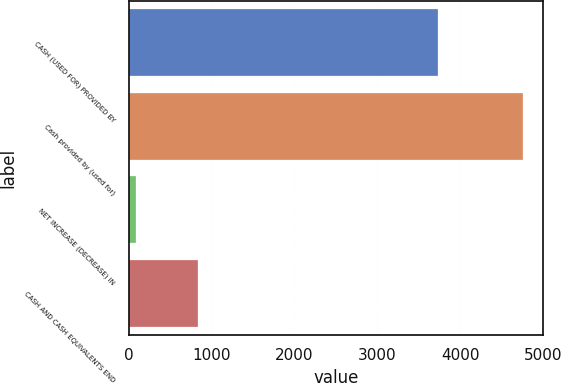Convert chart. <chart><loc_0><loc_0><loc_500><loc_500><bar_chart><fcel>CASH (USED FOR) PROVIDED BY<fcel>Cash provided by (used for)<fcel>NET INCREASE (DECREASE) IN<fcel>CASH AND CASH EQUIVALENTS END<nl><fcel>3731<fcel>4762<fcel>80<fcel>836<nl></chart> 